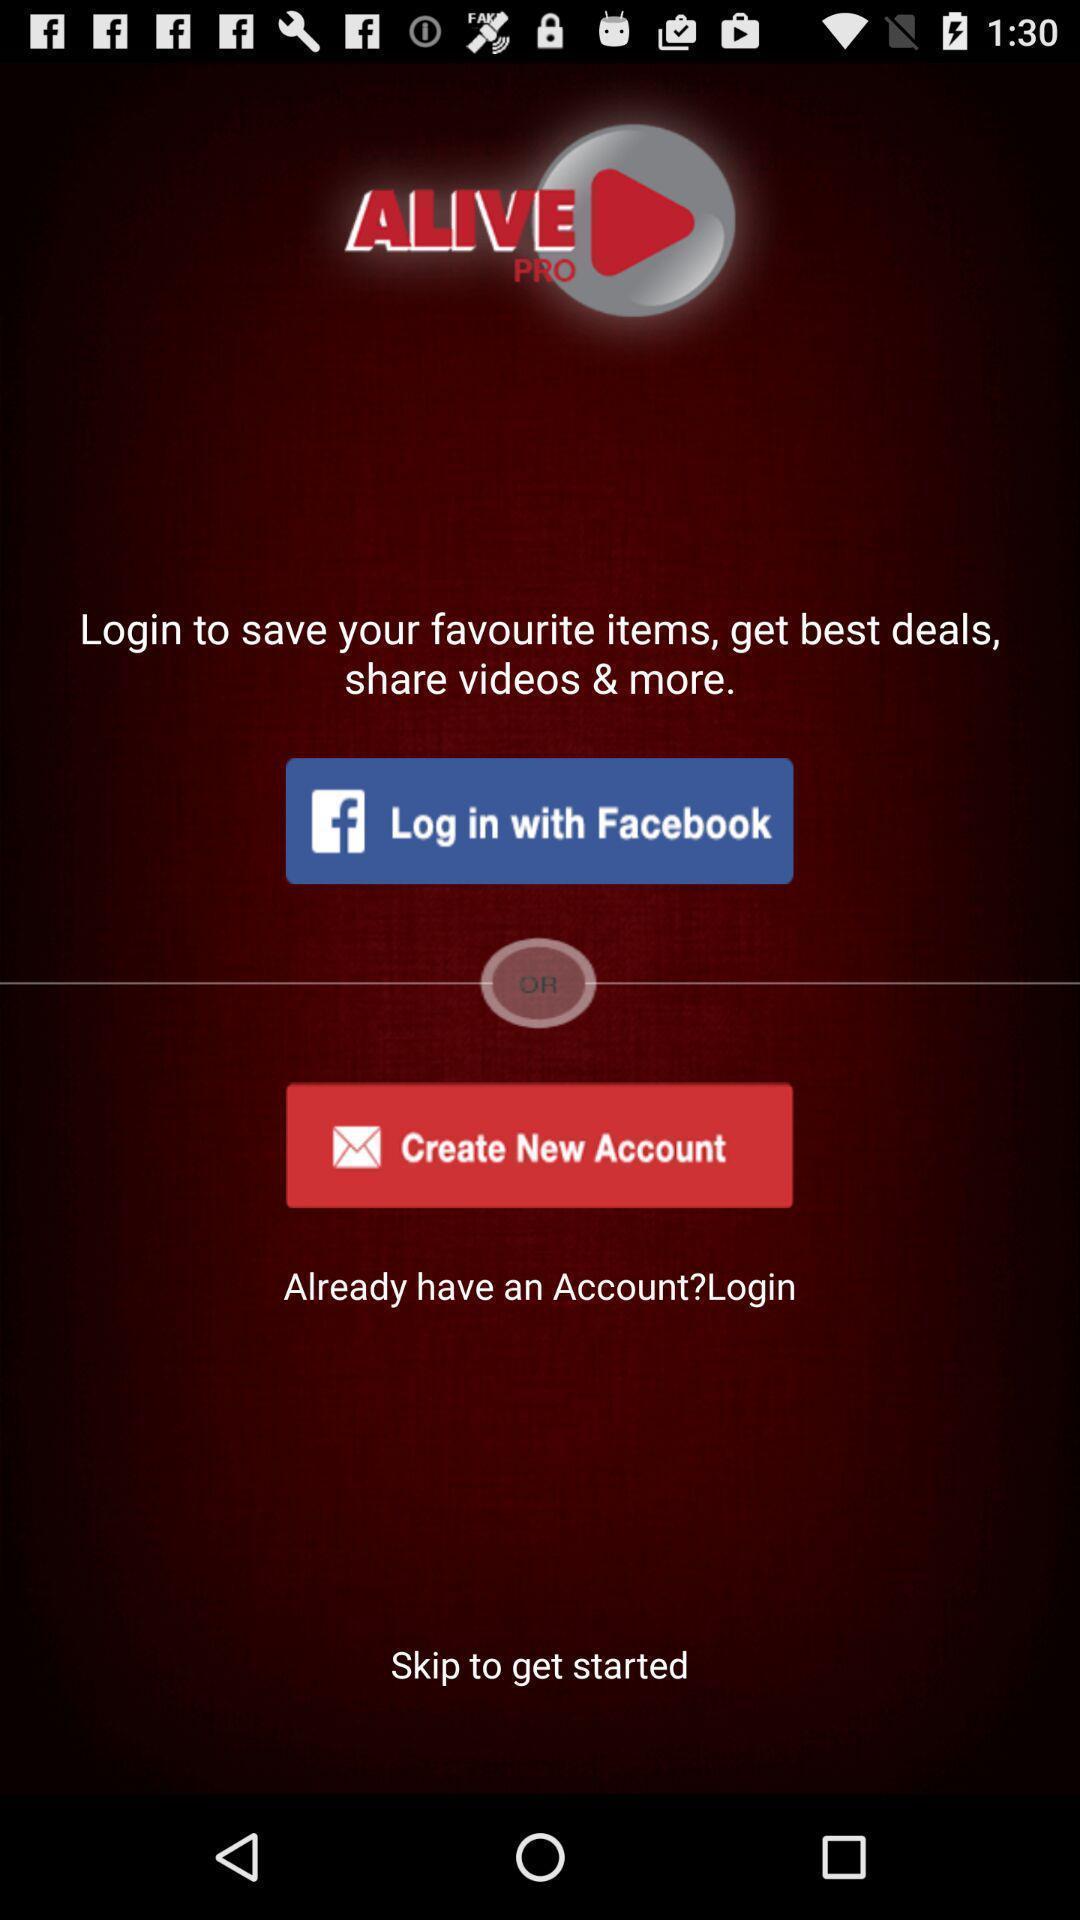Tell me about the visual elements in this screen capture. Welcome page. 